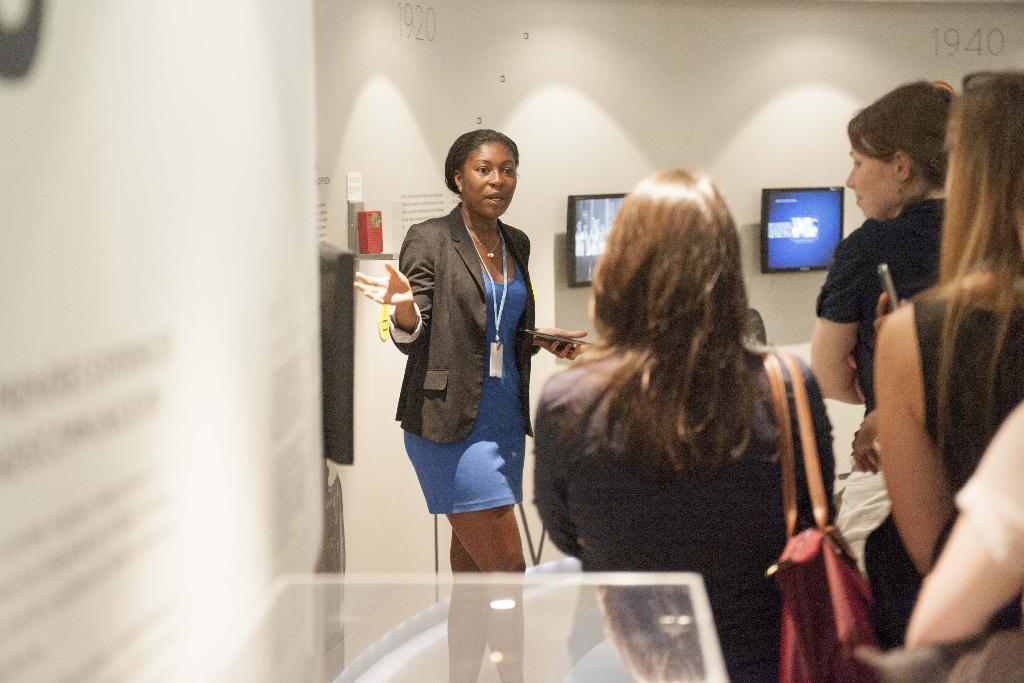How would you summarize this image in a sentence or two? In this image I can see the group of people standing and wearing the different color dresses. I can see one person is wearing the bag and another person with identification card. In the background I can see the screens to the wall. 